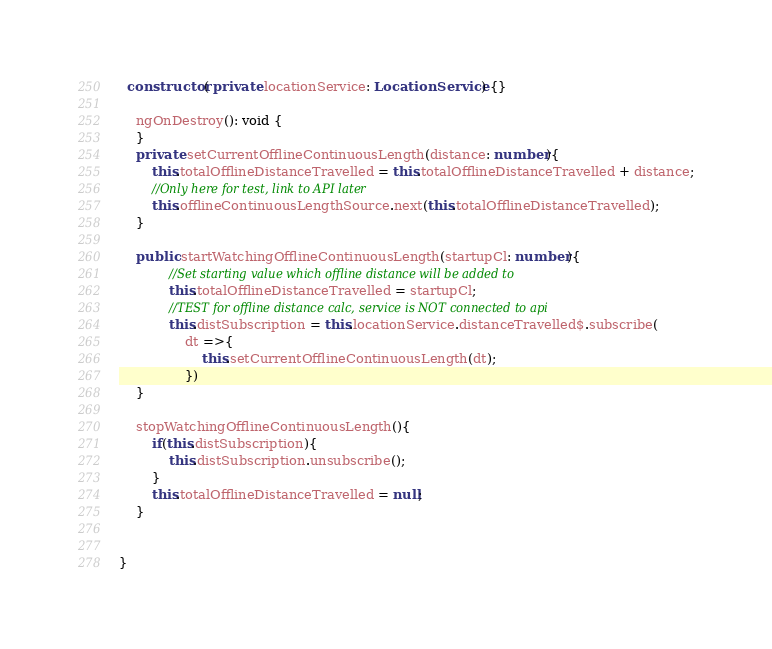Convert code to text. <code><loc_0><loc_0><loc_500><loc_500><_TypeScript_>
  constructor( private locationService: LocationService) {}

    ngOnDestroy(): void {
    }
    private setCurrentOfflineContinuousLength(distance: number){
        this.totalOfflineDistanceTravelled = this.totalOfflineDistanceTravelled + distance;
        //Only here for test, link to API later
        this.offlineContinuousLengthSource.next(this.totalOfflineDistanceTravelled);
    }

    public startWatchingOfflineContinuousLength(startupCl: number){
            //Set starting value which offline distance will be added to
            this.totalOfflineDistanceTravelled = startupCl;
            //TEST for offline distance calc, service is NOT connected to api
            this.distSubscription = this.locationService.distanceTravelled$.subscribe(
                dt =>{
                    this.setCurrentOfflineContinuousLength(dt);
                })
    }

    stopWatchingOfflineContinuousLength(){
        if(this.distSubscription){
            this.distSubscription.unsubscribe();
        }
        this.totalOfflineDistanceTravelled = null;
    }


}
</code> 